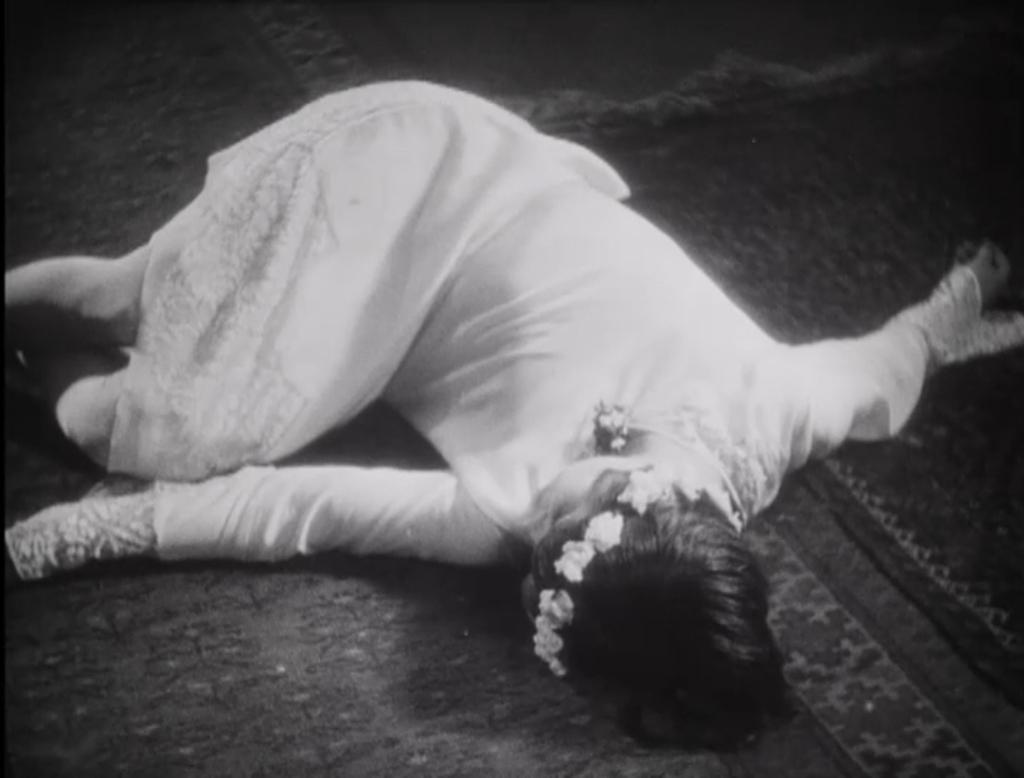Who is present in the image? There is a person in the image. What is the person wearing? The person is wearing a white dress and a flower headband. What is the person doing in the image? The person is sleeping on the ground. What type of wood or steel material is used to create the person's headband in the image? The person's headband is a flower headband, and it does not appear to be made of wood or steel. 